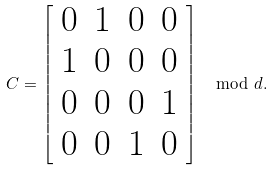<formula> <loc_0><loc_0><loc_500><loc_500>C = \left [ \begin{array} { c c c c } 0 & 1 & 0 & 0 \\ 1 & 0 & 0 & 0 \\ 0 & 0 & 0 & 1 \\ 0 & 0 & 1 & 0 \end{array} \right ] \mod d .</formula> 